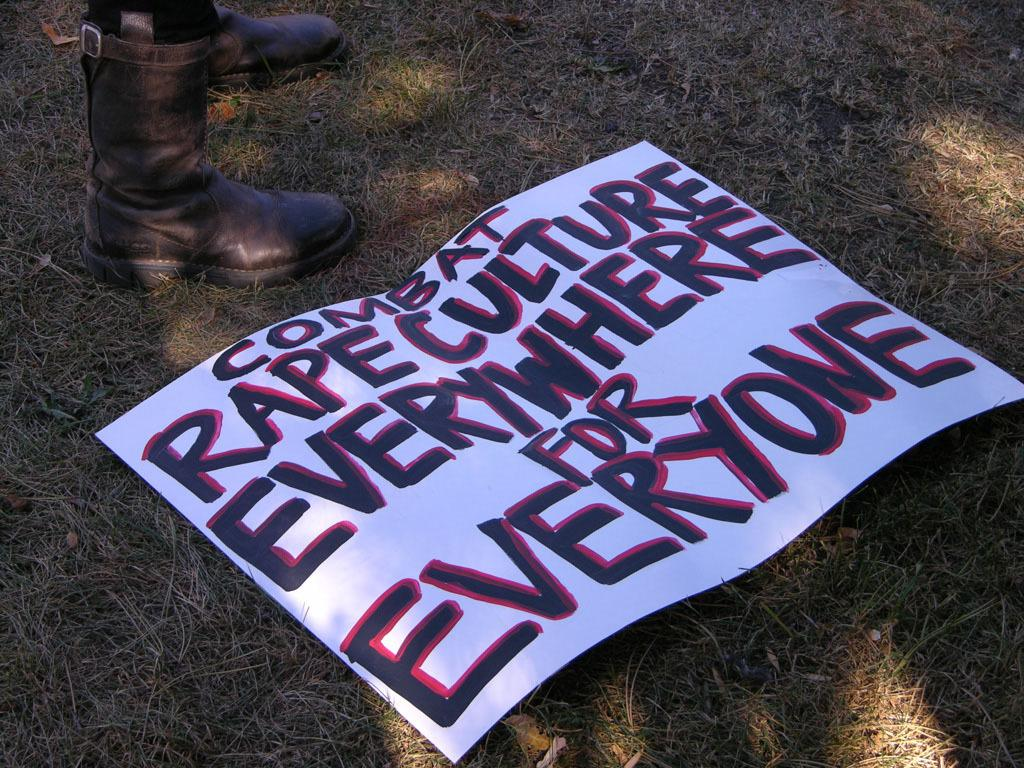What type of footwear is visible on the legs in the image? There are boots visible on the legs in the image. What is the paper with text used for in the image? The purpose of the paper with text is not clear from the image, but it is present. What type of terrain is visible in the image? There is grass on the ground in the image. What is the tax rate for the rod in the image? There is no rod or tax rate mentioned in the image. 